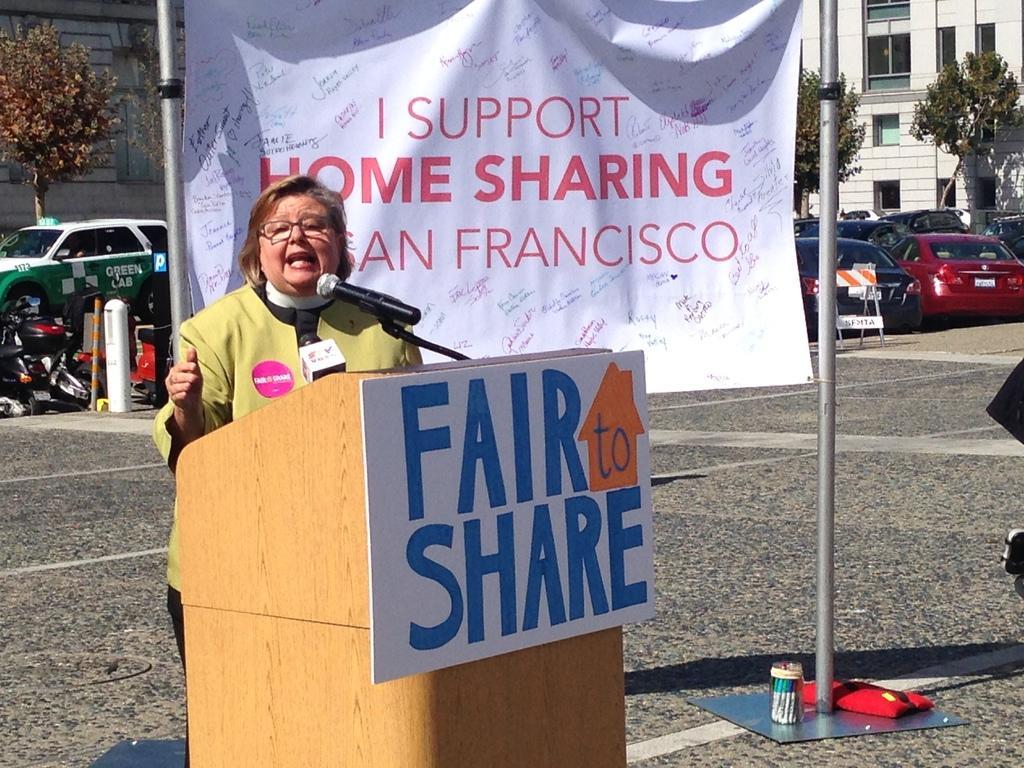Can you describe this image briefly? This is an outside view. On the left side there is a woman standing in front of the podium and speaking on a mike. To the podium a board is attached. On the board, I can see some text. At the back of this woman there is a banner attached to the two poles. On the banner I can see some text. In the background there are many cars on the road and also I can see few trees and buildings. On the left side there are few objects on the ground. 